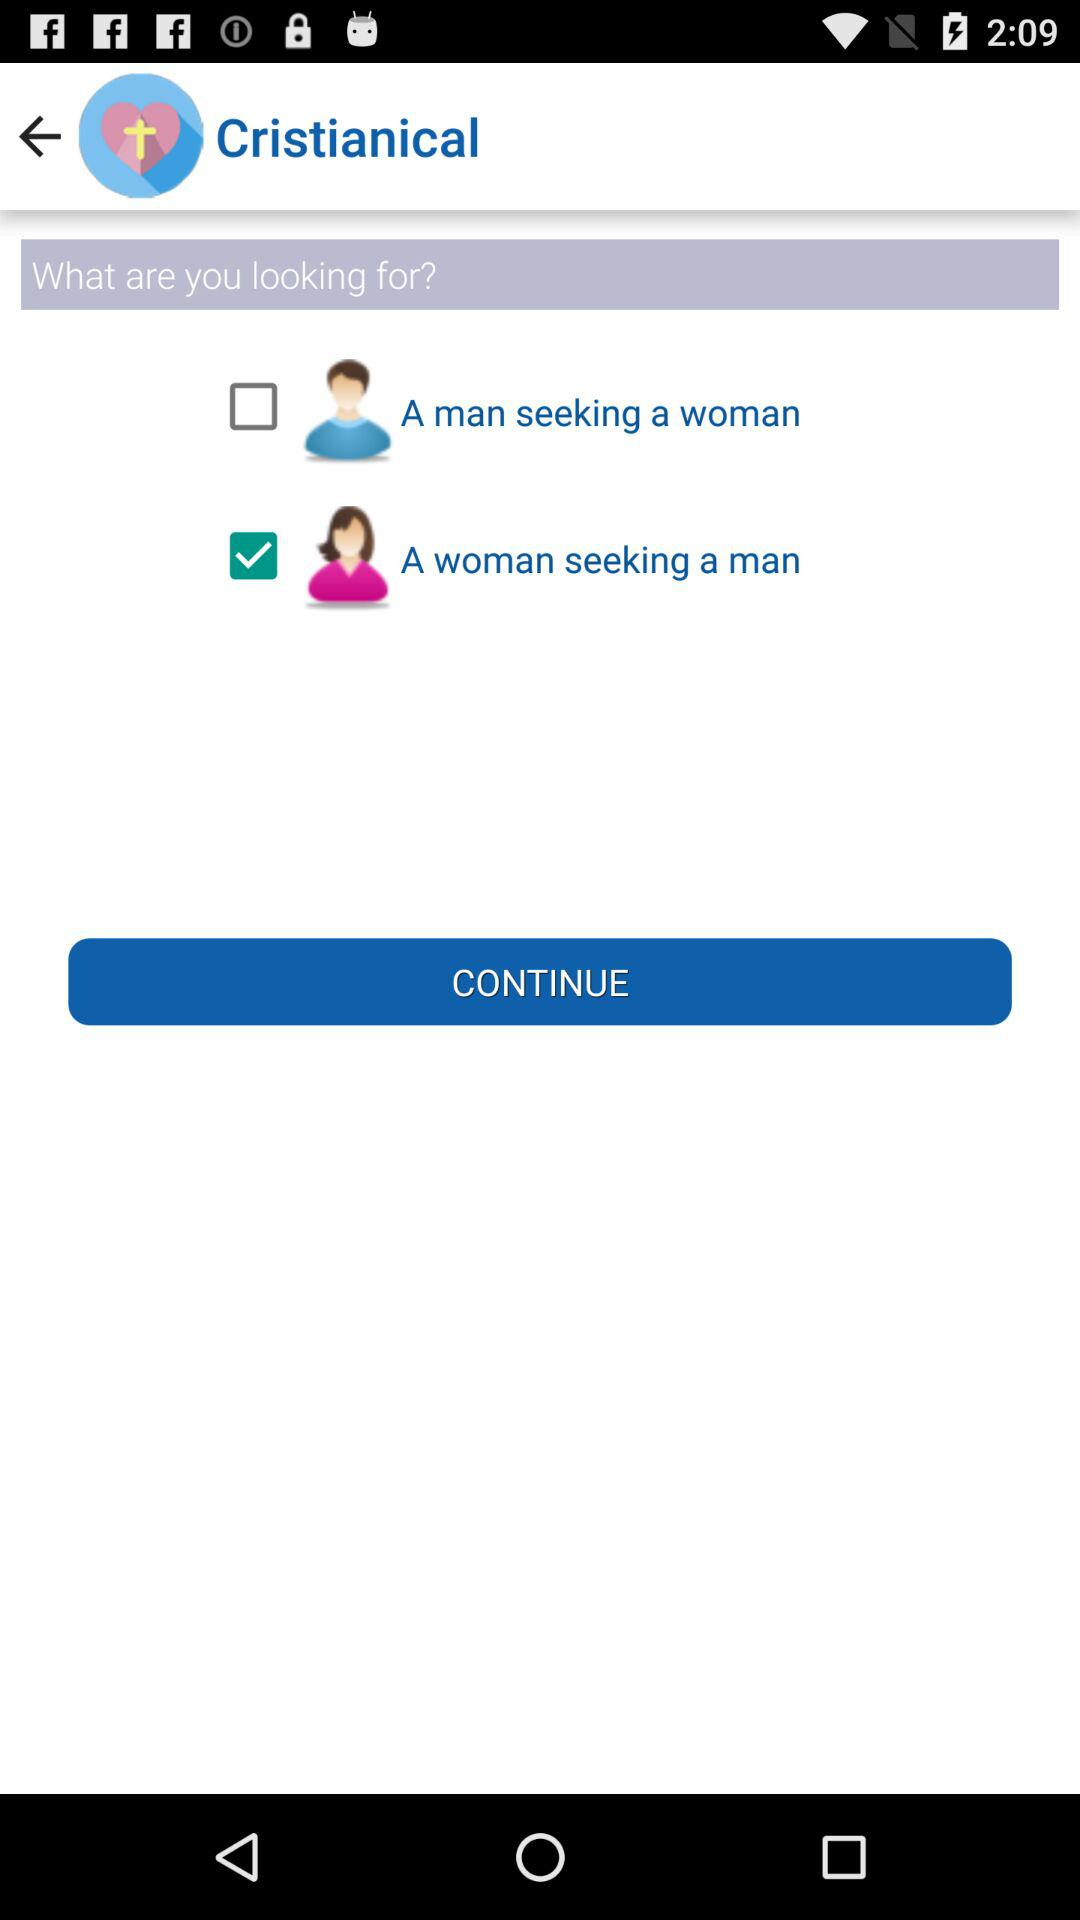Which option is checked in "What are you looking for"? The checked option is "A woman seeking a man". 